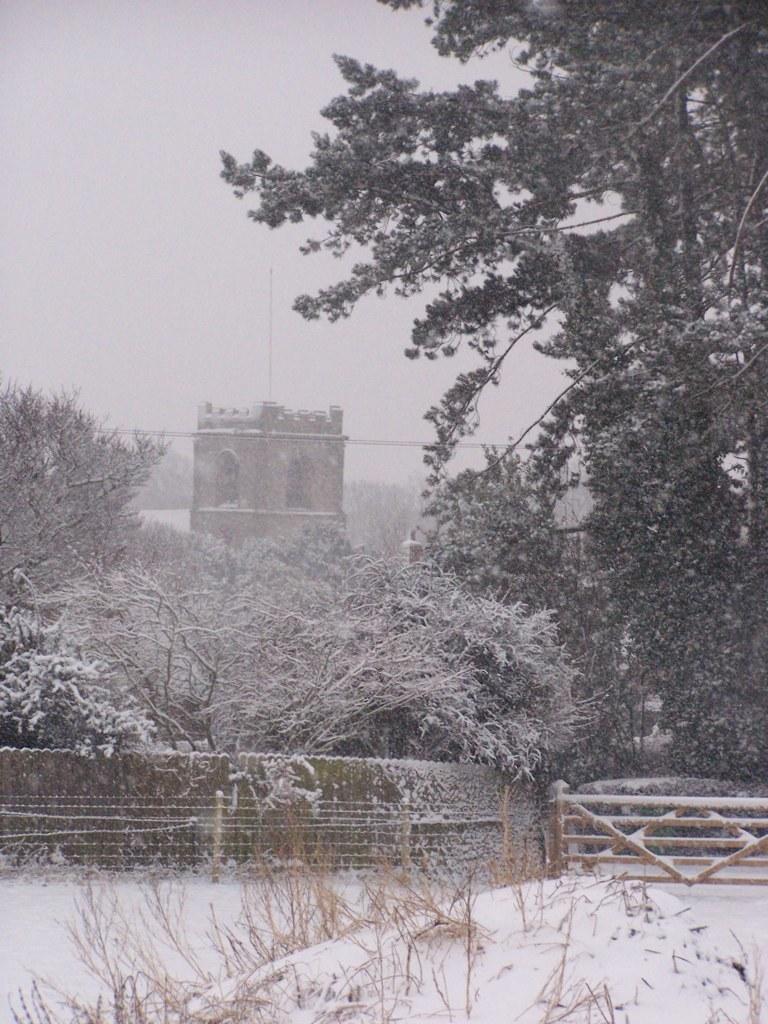Please provide a concise description of this image. In this picture there are trees and a fence wall covered with snow. 